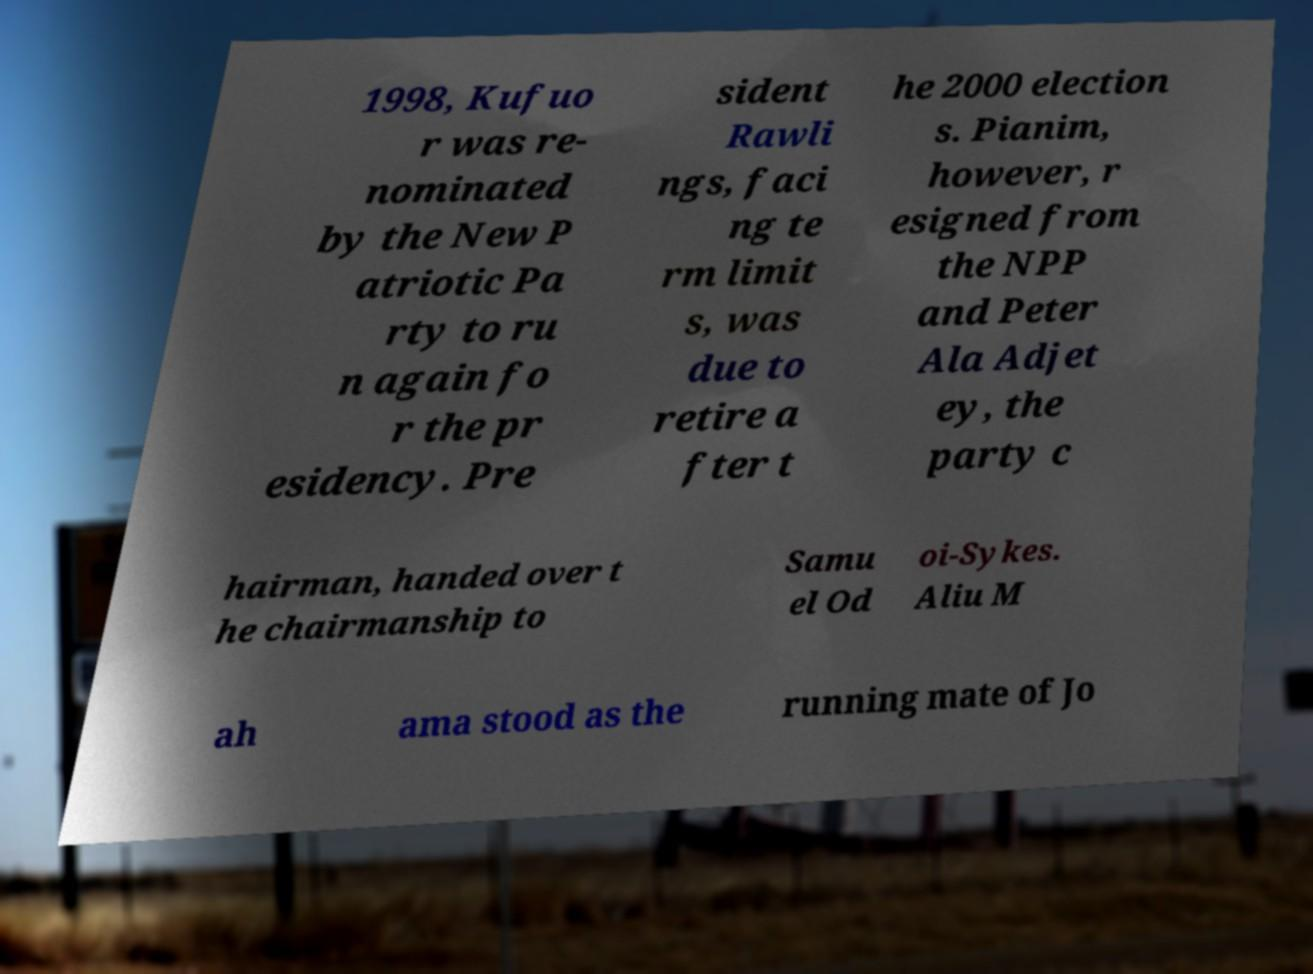Please identify and transcribe the text found in this image. 1998, Kufuo r was re- nominated by the New P atriotic Pa rty to ru n again fo r the pr esidency. Pre sident Rawli ngs, faci ng te rm limit s, was due to retire a fter t he 2000 election s. Pianim, however, r esigned from the NPP and Peter Ala Adjet ey, the party c hairman, handed over t he chairmanship to Samu el Od oi-Sykes. Aliu M ah ama stood as the running mate of Jo 